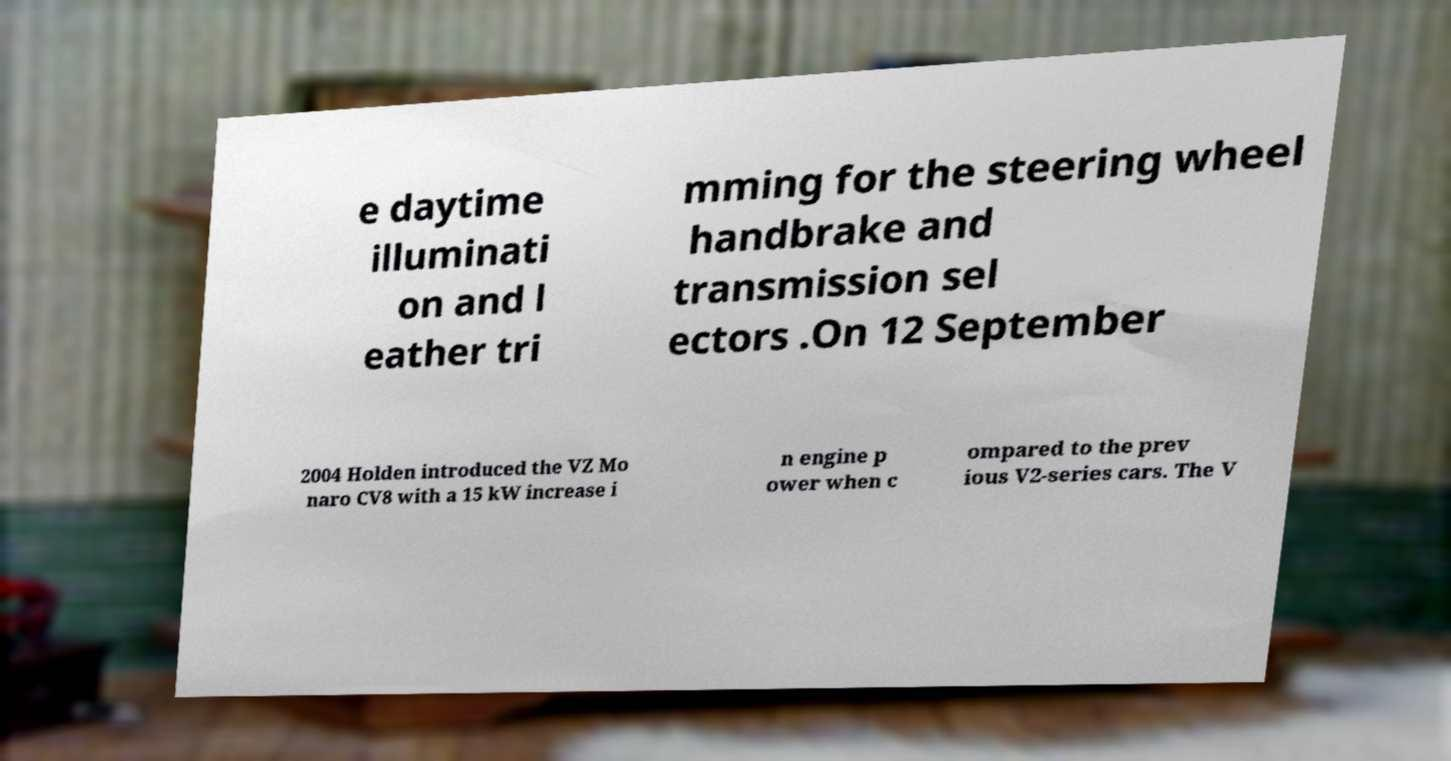For documentation purposes, I need the text within this image transcribed. Could you provide that? e daytime illuminati on and l eather tri mming for the steering wheel handbrake and transmission sel ectors .On 12 September 2004 Holden introduced the VZ Mo naro CV8 with a 15 kW increase i n engine p ower when c ompared to the prev ious V2-series cars. The V 